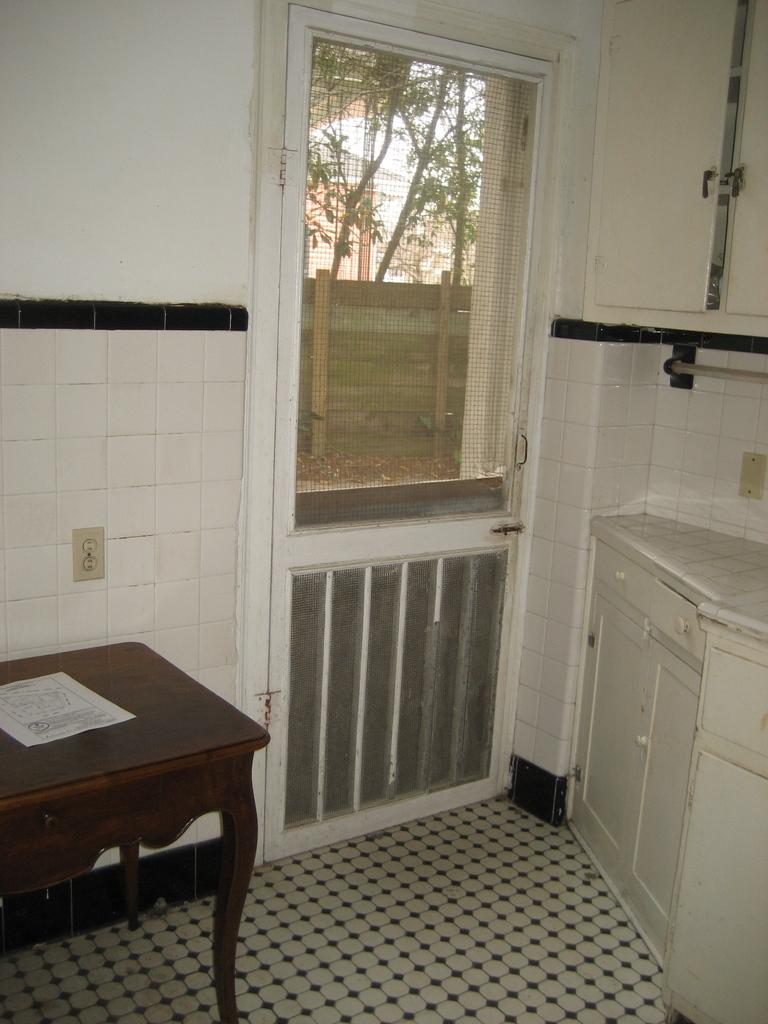What type of furniture is present in the image? There is a table in the image. What type of architectural feature can be seen in the image? There is a wall in the image. What type of access point is visible in the image? There is a door in the image. What can be seen through the door in the image? Trees are visible from the door in the image. What type of sheet is covering the door in the image? There is no sheet covering the door in the image. What word is written on the wall in the image? There is no word written on the wall in the image. What type of spark can be seen coming from the table in the image? There is no spark visible in the image. 